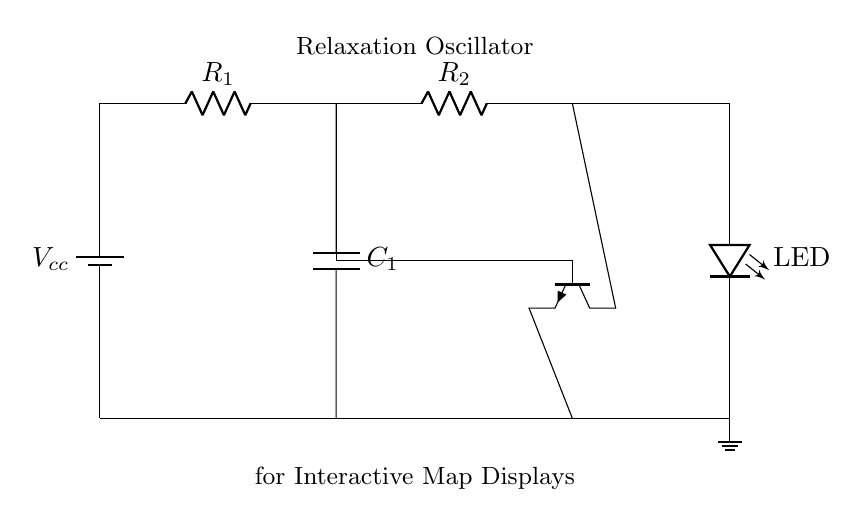What type of oscillator is shown in the circuit? The circuit is a relaxation oscillator, indicated by the components used, such as the capacitor and transistor, which are typically part of relaxation oscillator design.
Answer: relaxation oscillator What component is responsible for the flashing light? The LED is responsible for the flashing light in this circuit, as it is directly connected to the output of the oscillator circuit.
Answer: LED What is the role of the capacitor in this circuit? The capacitor is used to store and release energy, creating the timing intervals that result in the oscillation and thus the flashing effect.
Answer: timing How many resistors are in the circuit? There are two resistors in the circuit, labeled as R1 and R2, showing their positions and connections to other components.
Answer: 2 In which direction does the current flow through the LED? The current flows from the anode to the cathode of the LED, which is indicated by the connection to the higher potential side in the circuit.
Answer: anode to cathode Why is a transistor used in this circuit? The transistor is used as a switch or amplifier to control the operation of the LED, enabling the oscillation effect by turning the LED on and off rapidly.
Answer: switch 